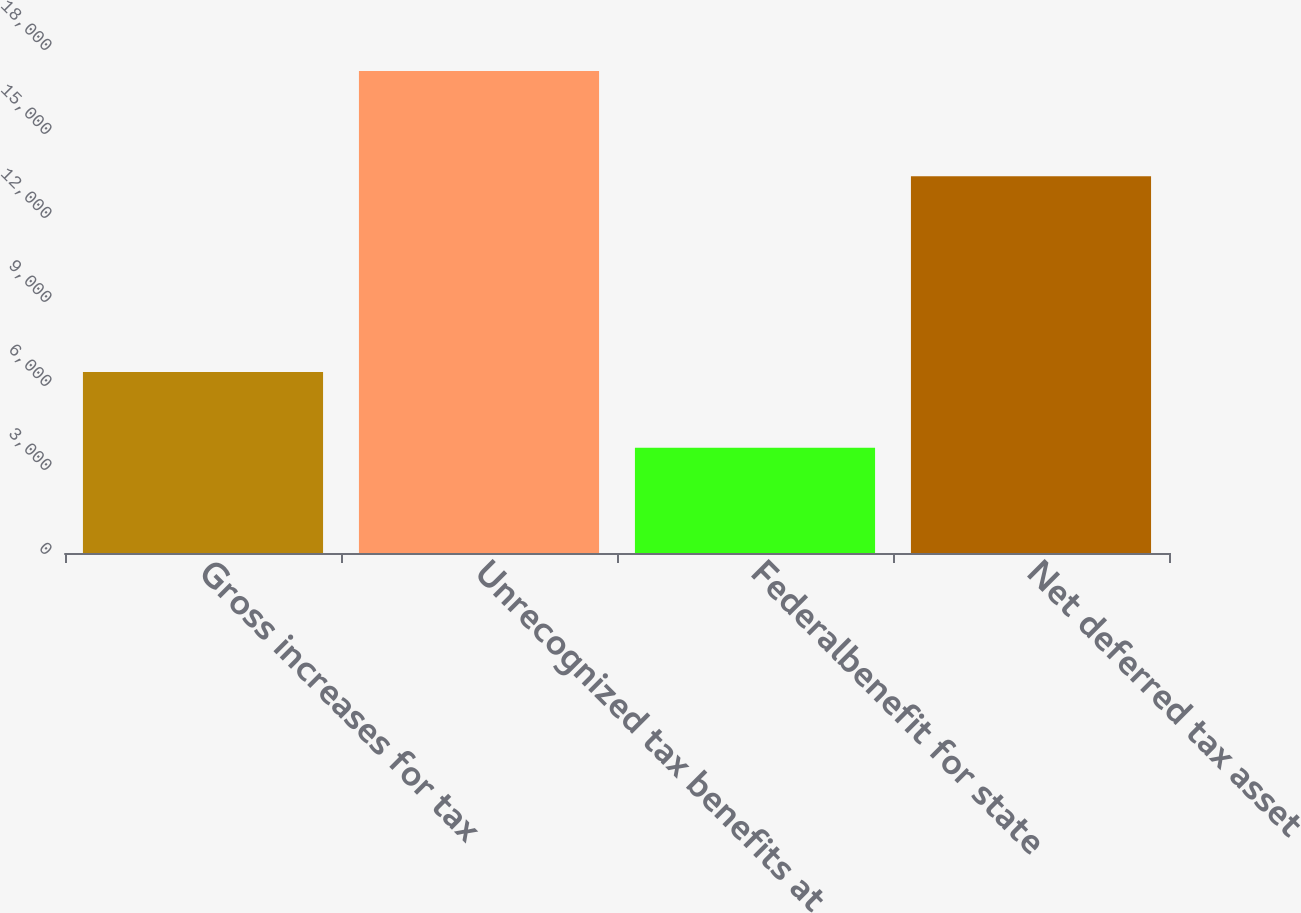<chart> <loc_0><loc_0><loc_500><loc_500><bar_chart><fcel>Gross increases for tax<fcel>Unrecognized tax benefits at<fcel>Federalbenefit for state<fcel>Net deferred tax asset<nl><fcel>6464<fcel>17214<fcel>3763<fcel>13451<nl></chart> 